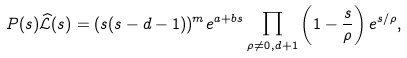<formula> <loc_0><loc_0><loc_500><loc_500>P ( s ) \widehat { \mathcal { L } } ( s ) = ( s ( s - d - 1 ) ) ^ { m } e ^ { a + b s } \prod _ { \rho \not = 0 , d + 1 } \left ( 1 - \frac { s } { \rho } \right ) e ^ { s / \rho } ,</formula> 